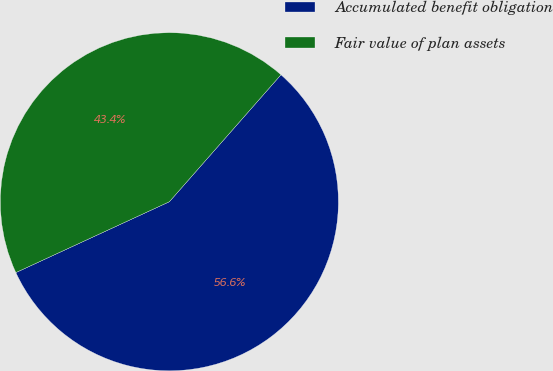Convert chart. <chart><loc_0><loc_0><loc_500><loc_500><pie_chart><fcel>Accumulated benefit obligation<fcel>Fair value of plan assets<nl><fcel>56.64%<fcel>43.36%<nl></chart> 